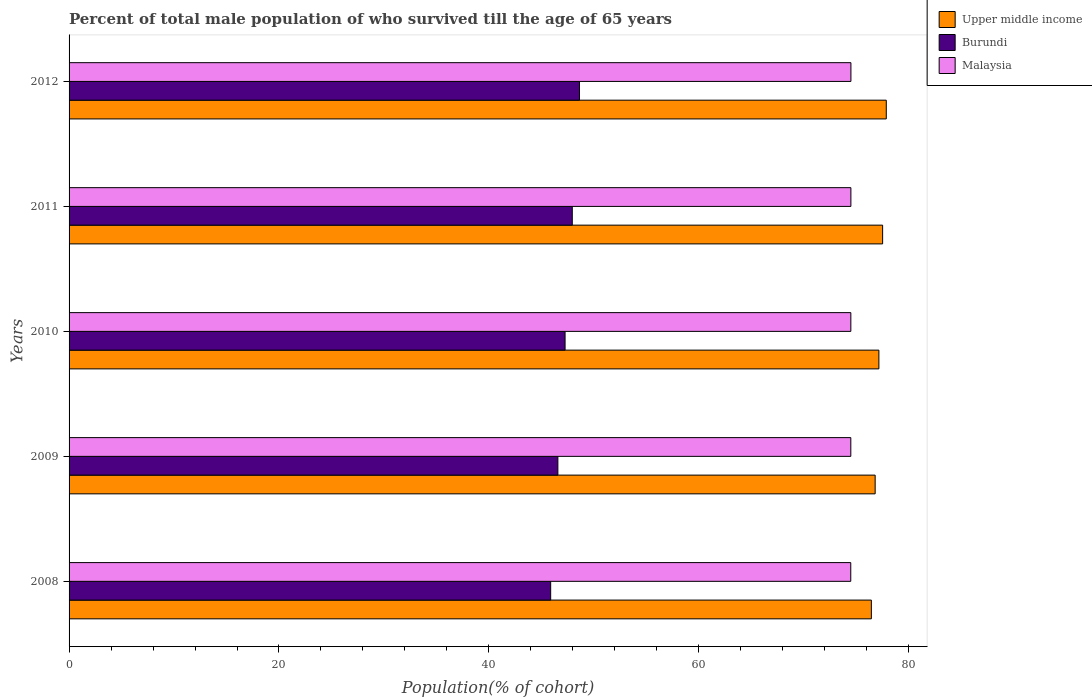How many bars are there on the 5th tick from the top?
Make the answer very short. 3. How many bars are there on the 5th tick from the bottom?
Keep it short and to the point. 3. What is the percentage of total male population who survived till the age of 65 years in Upper middle income in 2010?
Keep it short and to the point. 77.16. Across all years, what is the maximum percentage of total male population who survived till the age of 65 years in Burundi?
Offer a terse response. 48.63. Across all years, what is the minimum percentage of total male population who survived till the age of 65 years in Burundi?
Ensure brevity in your answer.  45.89. In which year was the percentage of total male population who survived till the age of 65 years in Malaysia maximum?
Make the answer very short. 2012. In which year was the percentage of total male population who survived till the age of 65 years in Burundi minimum?
Provide a succinct answer. 2008. What is the total percentage of total male population who survived till the age of 65 years in Upper middle income in the graph?
Make the answer very short. 385.78. What is the difference between the percentage of total male population who survived till the age of 65 years in Burundi in 2008 and that in 2012?
Offer a very short reply. -2.75. What is the difference between the percentage of total male population who survived till the age of 65 years in Upper middle income in 2009 and the percentage of total male population who survived till the age of 65 years in Burundi in 2008?
Your response must be concise. 30.92. What is the average percentage of total male population who survived till the age of 65 years in Malaysia per year?
Provide a succinct answer. 74.49. In the year 2011, what is the difference between the percentage of total male population who survived till the age of 65 years in Malaysia and percentage of total male population who survived till the age of 65 years in Burundi?
Provide a succinct answer. 26.55. What is the ratio of the percentage of total male population who survived till the age of 65 years in Burundi in 2008 to that in 2011?
Keep it short and to the point. 0.96. Is the percentage of total male population who survived till the age of 65 years in Burundi in 2008 less than that in 2009?
Provide a succinct answer. Yes. What is the difference between the highest and the second highest percentage of total male population who survived till the age of 65 years in Burundi?
Your answer should be compact. 0.69. What is the difference between the highest and the lowest percentage of total male population who survived till the age of 65 years in Malaysia?
Offer a terse response. 0.02. In how many years, is the percentage of total male population who survived till the age of 65 years in Upper middle income greater than the average percentage of total male population who survived till the age of 65 years in Upper middle income taken over all years?
Make the answer very short. 3. Is the sum of the percentage of total male population who survived till the age of 65 years in Malaysia in 2010 and 2012 greater than the maximum percentage of total male population who survived till the age of 65 years in Burundi across all years?
Give a very brief answer. Yes. What does the 2nd bar from the top in 2009 represents?
Provide a succinct answer. Burundi. What does the 1st bar from the bottom in 2008 represents?
Give a very brief answer. Upper middle income. Is it the case that in every year, the sum of the percentage of total male population who survived till the age of 65 years in Malaysia and percentage of total male population who survived till the age of 65 years in Burundi is greater than the percentage of total male population who survived till the age of 65 years in Upper middle income?
Make the answer very short. Yes. How many years are there in the graph?
Provide a short and direct response. 5. Are the values on the major ticks of X-axis written in scientific E-notation?
Offer a terse response. No. Does the graph contain grids?
Your response must be concise. No. How many legend labels are there?
Keep it short and to the point. 3. How are the legend labels stacked?
Provide a succinct answer. Vertical. What is the title of the graph?
Provide a short and direct response. Percent of total male population of who survived till the age of 65 years. Does "Andorra" appear as one of the legend labels in the graph?
Provide a short and direct response. No. What is the label or title of the X-axis?
Provide a short and direct response. Population(% of cohort). What is the Population(% of cohort) of Upper middle income in 2008?
Offer a terse response. 76.44. What is the Population(% of cohort) of Burundi in 2008?
Ensure brevity in your answer.  45.89. What is the Population(% of cohort) of Malaysia in 2008?
Your answer should be very brief. 74.48. What is the Population(% of cohort) of Upper middle income in 2009?
Provide a short and direct response. 76.8. What is the Population(% of cohort) in Burundi in 2009?
Make the answer very short. 46.57. What is the Population(% of cohort) in Malaysia in 2009?
Provide a short and direct response. 74.48. What is the Population(% of cohort) in Upper middle income in 2010?
Your response must be concise. 77.16. What is the Population(% of cohort) of Burundi in 2010?
Ensure brevity in your answer.  47.26. What is the Population(% of cohort) of Malaysia in 2010?
Offer a very short reply. 74.49. What is the Population(% of cohort) of Upper middle income in 2011?
Give a very brief answer. 77.51. What is the Population(% of cohort) of Burundi in 2011?
Offer a very short reply. 47.95. What is the Population(% of cohort) of Malaysia in 2011?
Your answer should be very brief. 74.49. What is the Population(% of cohort) in Upper middle income in 2012?
Offer a terse response. 77.86. What is the Population(% of cohort) of Burundi in 2012?
Keep it short and to the point. 48.63. What is the Population(% of cohort) in Malaysia in 2012?
Provide a succinct answer. 74.49. Across all years, what is the maximum Population(% of cohort) in Upper middle income?
Provide a short and direct response. 77.86. Across all years, what is the maximum Population(% of cohort) in Burundi?
Offer a terse response. 48.63. Across all years, what is the maximum Population(% of cohort) in Malaysia?
Offer a very short reply. 74.49. Across all years, what is the minimum Population(% of cohort) of Upper middle income?
Your response must be concise. 76.44. Across all years, what is the minimum Population(% of cohort) in Burundi?
Offer a very short reply. 45.89. Across all years, what is the minimum Population(% of cohort) in Malaysia?
Your answer should be very brief. 74.48. What is the total Population(% of cohort) of Upper middle income in the graph?
Make the answer very short. 385.78. What is the total Population(% of cohort) of Burundi in the graph?
Provide a succinct answer. 236.29. What is the total Population(% of cohort) in Malaysia in the graph?
Keep it short and to the point. 372.43. What is the difference between the Population(% of cohort) of Upper middle income in 2008 and that in 2009?
Offer a terse response. -0.36. What is the difference between the Population(% of cohort) of Burundi in 2008 and that in 2009?
Offer a terse response. -0.69. What is the difference between the Population(% of cohort) of Malaysia in 2008 and that in 2009?
Make the answer very short. -0. What is the difference between the Population(% of cohort) in Upper middle income in 2008 and that in 2010?
Provide a short and direct response. -0.72. What is the difference between the Population(% of cohort) in Burundi in 2008 and that in 2010?
Offer a very short reply. -1.37. What is the difference between the Population(% of cohort) of Malaysia in 2008 and that in 2010?
Provide a short and direct response. -0.01. What is the difference between the Population(% of cohort) of Upper middle income in 2008 and that in 2011?
Your response must be concise. -1.07. What is the difference between the Population(% of cohort) of Burundi in 2008 and that in 2011?
Ensure brevity in your answer.  -2.06. What is the difference between the Population(% of cohort) in Malaysia in 2008 and that in 2011?
Provide a short and direct response. -0.01. What is the difference between the Population(% of cohort) in Upper middle income in 2008 and that in 2012?
Ensure brevity in your answer.  -1.42. What is the difference between the Population(% of cohort) of Burundi in 2008 and that in 2012?
Offer a terse response. -2.75. What is the difference between the Population(% of cohort) of Malaysia in 2008 and that in 2012?
Make the answer very short. -0.02. What is the difference between the Population(% of cohort) in Upper middle income in 2009 and that in 2010?
Offer a very short reply. -0.36. What is the difference between the Population(% of cohort) in Burundi in 2009 and that in 2010?
Ensure brevity in your answer.  -0.69. What is the difference between the Population(% of cohort) of Malaysia in 2009 and that in 2010?
Your response must be concise. -0. What is the difference between the Population(% of cohort) of Upper middle income in 2009 and that in 2011?
Provide a short and direct response. -0.71. What is the difference between the Population(% of cohort) of Burundi in 2009 and that in 2011?
Offer a terse response. -1.37. What is the difference between the Population(% of cohort) of Malaysia in 2009 and that in 2011?
Make the answer very short. -0.01. What is the difference between the Population(% of cohort) of Upper middle income in 2009 and that in 2012?
Offer a terse response. -1.06. What is the difference between the Population(% of cohort) of Burundi in 2009 and that in 2012?
Provide a succinct answer. -2.06. What is the difference between the Population(% of cohort) of Malaysia in 2009 and that in 2012?
Offer a terse response. -0.01. What is the difference between the Population(% of cohort) in Upper middle income in 2010 and that in 2011?
Your answer should be compact. -0.36. What is the difference between the Population(% of cohort) of Burundi in 2010 and that in 2011?
Ensure brevity in your answer.  -0.69. What is the difference between the Population(% of cohort) of Malaysia in 2010 and that in 2011?
Provide a succinct answer. -0. What is the difference between the Population(% of cohort) in Upper middle income in 2010 and that in 2012?
Ensure brevity in your answer.  -0.7. What is the difference between the Population(% of cohort) of Burundi in 2010 and that in 2012?
Ensure brevity in your answer.  -1.37. What is the difference between the Population(% of cohort) in Malaysia in 2010 and that in 2012?
Offer a terse response. -0.01. What is the difference between the Population(% of cohort) in Upper middle income in 2011 and that in 2012?
Your answer should be compact. -0.35. What is the difference between the Population(% of cohort) in Burundi in 2011 and that in 2012?
Your answer should be very brief. -0.69. What is the difference between the Population(% of cohort) of Malaysia in 2011 and that in 2012?
Offer a terse response. -0. What is the difference between the Population(% of cohort) of Upper middle income in 2008 and the Population(% of cohort) of Burundi in 2009?
Your response must be concise. 29.87. What is the difference between the Population(% of cohort) in Upper middle income in 2008 and the Population(% of cohort) in Malaysia in 2009?
Provide a succinct answer. 1.96. What is the difference between the Population(% of cohort) of Burundi in 2008 and the Population(% of cohort) of Malaysia in 2009?
Offer a terse response. -28.6. What is the difference between the Population(% of cohort) of Upper middle income in 2008 and the Population(% of cohort) of Burundi in 2010?
Ensure brevity in your answer.  29.18. What is the difference between the Population(% of cohort) in Upper middle income in 2008 and the Population(% of cohort) in Malaysia in 2010?
Keep it short and to the point. 1.95. What is the difference between the Population(% of cohort) of Burundi in 2008 and the Population(% of cohort) of Malaysia in 2010?
Make the answer very short. -28.6. What is the difference between the Population(% of cohort) in Upper middle income in 2008 and the Population(% of cohort) in Burundi in 2011?
Provide a succinct answer. 28.5. What is the difference between the Population(% of cohort) of Upper middle income in 2008 and the Population(% of cohort) of Malaysia in 2011?
Your answer should be very brief. 1.95. What is the difference between the Population(% of cohort) in Burundi in 2008 and the Population(% of cohort) in Malaysia in 2011?
Offer a very short reply. -28.6. What is the difference between the Population(% of cohort) in Upper middle income in 2008 and the Population(% of cohort) in Burundi in 2012?
Offer a terse response. 27.81. What is the difference between the Population(% of cohort) in Upper middle income in 2008 and the Population(% of cohort) in Malaysia in 2012?
Ensure brevity in your answer.  1.95. What is the difference between the Population(% of cohort) of Burundi in 2008 and the Population(% of cohort) of Malaysia in 2012?
Your answer should be compact. -28.61. What is the difference between the Population(% of cohort) of Upper middle income in 2009 and the Population(% of cohort) of Burundi in 2010?
Your answer should be compact. 29.54. What is the difference between the Population(% of cohort) in Upper middle income in 2009 and the Population(% of cohort) in Malaysia in 2010?
Offer a terse response. 2.32. What is the difference between the Population(% of cohort) of Burundi in 2009 and the Population(% of cohort) of Malaysia in 2010?
Your answer should be very brief. -27.91. What is the difference between the Population(% of cohort) in Upper middle income in 2009 and the Population(% of cohort) in Burundi in 2011?
Provide a succinct answer. 28.86. What is the difference between the Population(% of cohort) of Upper middle income in 2009 and the Population(% of cohort) of Malaysia in 2011?
Your response must be concise. 2.31. What is the difference between the Population(% of cohort) in Burundi in 2009 and the Population(% of cohort) in Malaysia in 2011?
Provide a succinct answer. -27.92. What is the difference between the Population(% of cohort) of Upper middle income in 2009 and the Population(% of cohort) of Burundi in 2012?
Your response must be concise. 28.17. What is the difference between the Population(% of cohort) of Upper middle income in 2009 and the Population(% of cohort) of Malaysia in 2012?
Ensure brevity in your answer.  2.31. What is the difference between the Population(% of cohort) of Burundi in 2009 and the Population(% of cohort) of Malaysia in 2012?
Your answer should be compact. -27.92. What is the difference between the Population(% of cohort) of Upper middle income in 2010 and the Population(% of cohort) of Burundi in 2011?
Make the answer very short. 29.21. What is the difference between the Population(% of cohort) in Upper middle income in 2010 and the Population(% of cohort) in Malaysia in 2011?
Give a very brief answer. 2.67. What is the difference between the Population(% of cohort) in Burundi in 2010 and the Population(% of cohort) in Malaysia in 2011?
Provide a succinct answer. -27.23. What is the difference between the Population(% of cohort) in Upper middle income in 2010 and the Population(% of cohort) in Burundi in 2012?
Give a very brief answer. 28.53. What is the difference between the Population(% of cohort) of Upper middle income in 2010 and the Population(% of cohort) of Malaysia in 2012?
Make the answer very short. 2.66. What is the difference between the Population(% of cohort) in Burundi in 2010 and the Population(% of cohort) in Malaysia in 2012?
Offer a very short reply. -27.24. What is the difference between the Population(% of cohort) in Upper middle income in 2011 and the Population(% of cohort) in Burundi in 2012?
Offer a very short reply. 28.88. What is the difference between the Population(% of cohort) in Upper middle income in 2011 and the Population(% of cohort) in Malaysia in 2012?
Make the answer very short. 3.02. What is the difference between the Population(% of cohort) of Burundi in 2011 and the Population(% of cohort) of Malaysia in 2012?
Your answer should be compact. -26.55. What is the average Population(% of cohort) in Upper middle income per year?
Offer a terse response. 77.16. What is the average Population(% of cohort) in Burundi per year?
Provide a succinct answer. 47.26. What is the average Population(% of cohort) in Malaysia per year?
Make the answer very short. 74.49. In the year 2008, what is the difference between the Population(% of cohort) of Upper middle income and Population(% of cohort) of Burundi?
Offer a very short reply. 30.56. In the year 2008, what is the difference between the Population(% of cohort) in Upper middle income and Population(% of cohort) in Malaysia?
Provide a succinct answer. 1.96. In the year 2008, what is the difference between the Population(% of cohort) of Burundi and Population(% of cohort) of Malaysia?
Give a very brief answer. -28.59. In the year 2009, what is the difference between the Population(% of cohort) in Upper middle income and Population(% of cohort) in Burundi?
Offer a terse response. 30.23. In the year 2009, what is the difference between the Population(% of cohort) of Upper middle income and Population(% of cohort) of Malaysia?
Your answer should be very brief. 2.32. In the year 2009, what is the difference between the Population(% of cohort) of Burundi and Population(% of cohort) of Malaysia?
Provide a succinct answer. -27.91. In the year 2010, what is the difference between the Population(% of cohort) of Upper middle income and Population(% of cohort) of Burundi?
Provide a succinct answer. 29.9. In the year 2010, what is the difference between the Population(% of cohort) of Upper middle income and Population(% of cohort) of Malaysia?
Offer a very short reply. 2.67. In the year 2010, what is the difference between the Population(% of cohort) of Burundi and Population(% of cohort) of Malaysia?
Give a very brief answer. -27.23. In the year 2011, what is the difference between the Population(% of cohort) of Upper middle income and Population(% of cohort) of Burundi?
Ensure brevity in your answer.  29.57. In the year 2011, what is the difference between the Population(% of cohort) of Upper middle income and Population(% of cohort) of Malaysia?
Your answer should be compact. 3.02. In the year 2011, what is the difference between the Population(% of cohort) of Burundi and Population(% of cohort) of Malaysia?
Provide a short and direct response. -26.55. In the year 2012, what is the difference between the Population(% of cohort) in Upper middle income and Population(% of cohort) in Burundi?
Your response must be concise. 29.23. In the year 2012, what is the difference between the Population(% of cohort) in Upper middle income and Population(% of cohort) in Malaysia?
Offer a terse response. 3.37. In the year 2012, what is the difference between the Population(% of cohort) of Burundi and Population(% of cohort) of Malaysia?
Offer a terse response. -25.86. What is the ratio of the Population(% of cohort) in Burundi in 2008 to that in 2009?
Provide a short and direct response. 0.99. What is the ratio of the Population(% of cohort) in Upper middle income in 2008 to that in 2010?
Offer a very short reply. 0.99. What is the ratio of the Population(% of cohort) of Burundi in 2008 to that in 2010?
Offer a terse response. 0.97. What is the ratio of the Population(% of cohort) of Upper middle income in 2008 to that in 2011?
Offer a terse response. 0.99. What is the ratio of the Population(% of cohort) of Burundi in 2008 to that in 2011?
Your response must be concise. 0.96. What is the ratio of the Population(% of cohort) in Upper middle income in 2008 to that in 2012?
Your answer should be very brief. 0.98. What is the ratio of the Population(% of cohort) of Burundi in 2008 to that in 2012?
Your answer should be very brief. 0.94. What is the ratio of the Population(% of cohort) of Malaysia in 2008 to that in 2012?
Make the answer very short. 1. What is the ratio of the Population(% of cohort) in Burundi in 2009 to that in 2010?
Ensure brevity in your answer.  0.99. What is the ratio of the Population(% of cohort) of Burundi in 2009 to that in 2011?
Your answer should be compact. 0.97. What is the ratio of the Population(% of cohort) of Upper middle income in 2009 to that in 2012?
Provide a succinct answer. 0.99. What is the ratio of the Population(% of cohort) of Burundi in 2009 to that in 2012?
Provide a succinct answer. 0.96. What is the ratio of the Population(% of cohort) in Burundi in 2010 to that in 2011?
Your answer should be compact. 0.99. What is the ratio of the Population(% of cohort) of Upper middle income in 2010 to that in 2012?
Your response must be concise. 0.99. What is the ratio of the Population(% of cohort) of Burundi in 2010 to that in 2012?
Offer a terse response. 0.97. What is the ratio of the Population(% of cohort) of Upper middle income in 2011 to that in 2012?
Offer a terse response. 1. What is the ratio of the Population(% of cohort) of Burundi in 2011 to that in 2012?
Your answer should be compact. 0.99. What is the difference between the highest and the second highest Population(% of cohort) of Upper middle income?
Your answer should be compact. 0.35. What is the difference between the highest and the second highest Population(% of cohort) in Burundi?
Give a very brief answer. 0.69. What is the difference between the highest and the second highest Population(% of cohort) in Malaysia?
Your answer should be compact. 0. What is the difference between the highest and the lowest Population(% of cohort) of Upper middle income?
Offer a very short reply. 1.42. What is the difference between the highest and the lowest Population(% of cohort) in Burundi?
Offer a terse response. 2.75. What is the difference between the highest and the lowest Population(% of cohort) of Malaysia?
Make the answer very short. 0.02. 